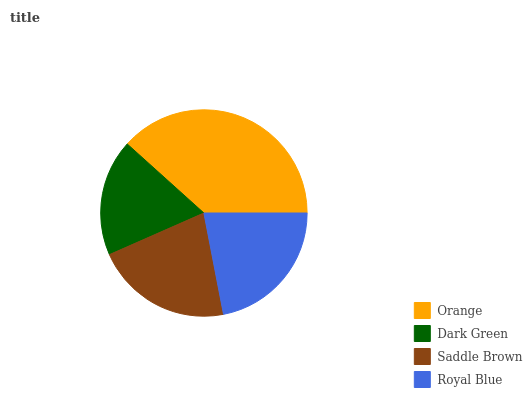Is Dark Green the minimum?
Answer yes or no. Yes. Is Orange the maximum?
Answer yes or no. Yes. Is Saddle Brown the minimum?
Answer yes or no. No. Is Saddle Brown the maximum?
Answer yes or no. No. Is Saddle Brown greater than Dark Green?
Answer yes or no. Yes. Is Dark Green less than Saddle Brown?
Answer yes or no. Yes. Is Dark Green greater than Saddle Brown?
Answer yes or no. No. Is Saddle Brown less than Dark Green?
Answer yes or no. No. Is Royal Blue the high median?
Answer yes or no. Yes. Is Saddle Brown the low median?
Answer yes or no. Yes. Is Saddle Brown the high median?
Answer yes or no. No. Is Dark Green the low median?
Answer yes or no. No. 